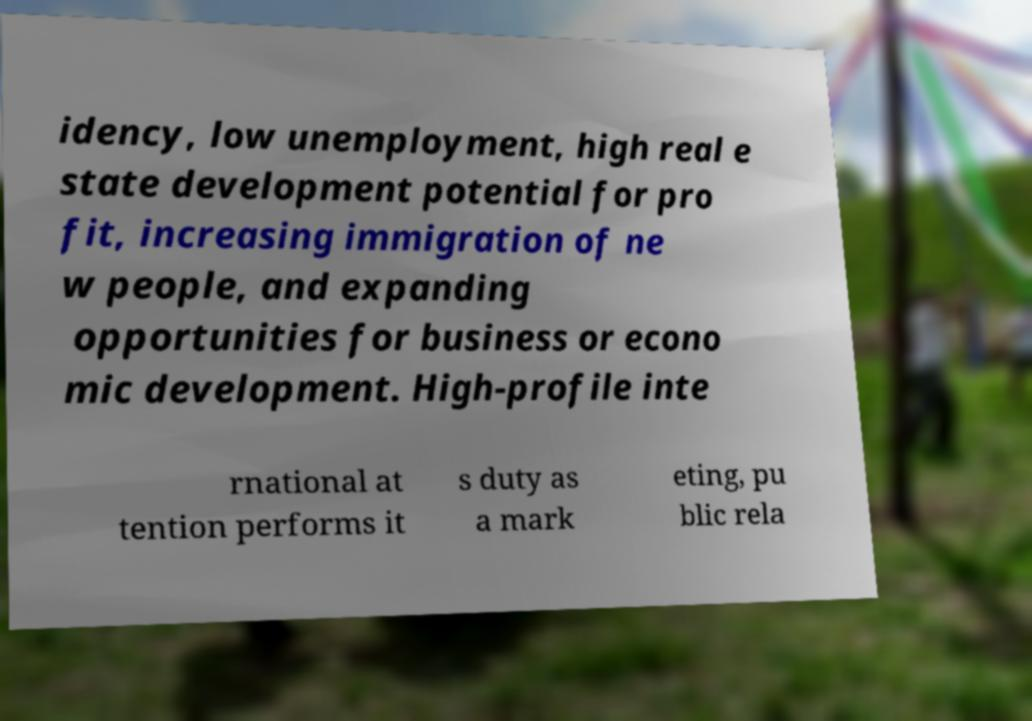Please read and relay the text visible in this image. What does it say? idency, low unemployment, high real e state development potential for pro fit, increasing immigration of ne w people, and expanding opportunities for business or econo mic development. High-profile inte rnational at tention performs it s duty as a mark eting, pu blic rela 